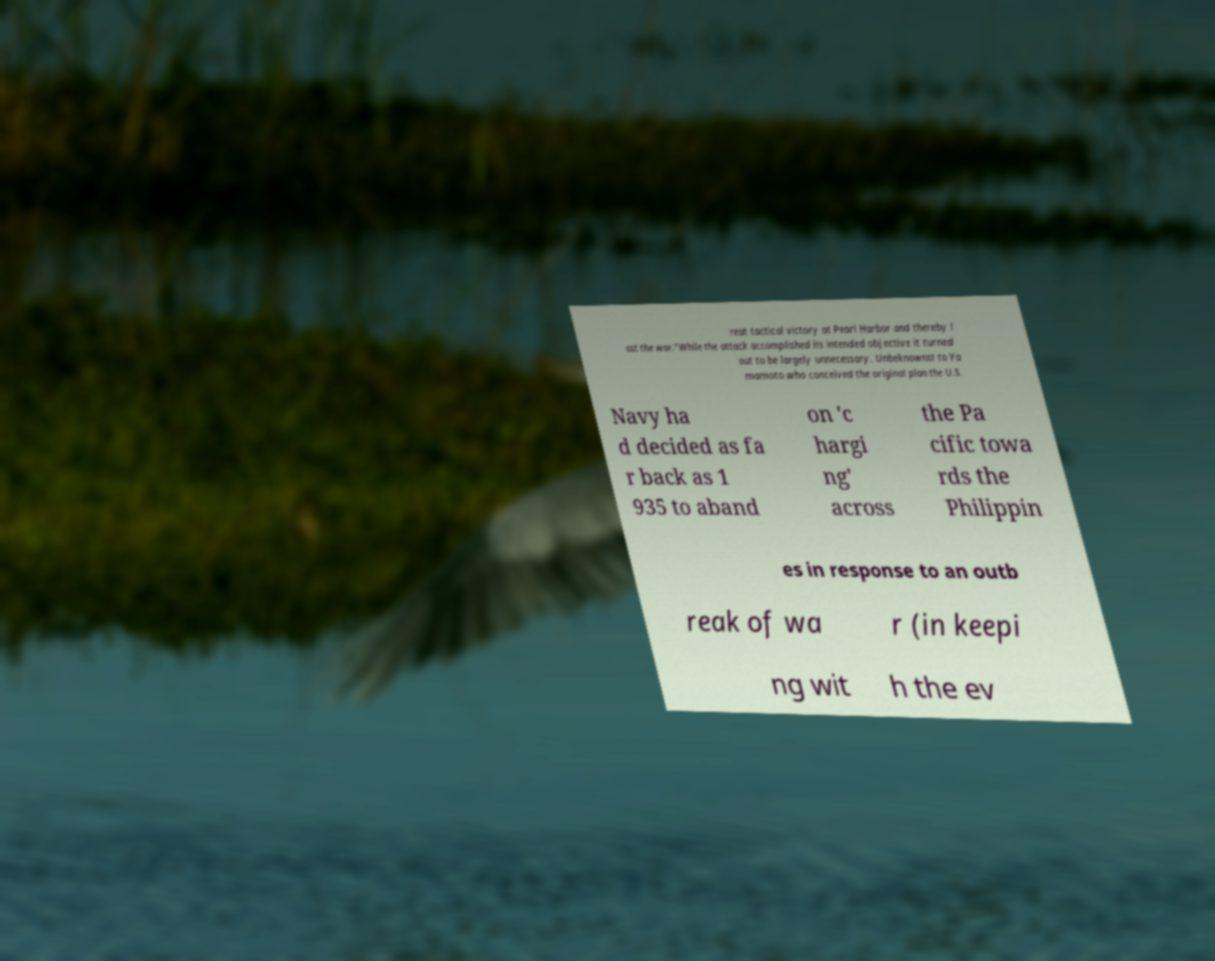Please read and relay the text visible in this image. What does it say? reat tactical victory at Pearl Harbor and thereby l ost the war."While the attack accomplished its intended objective it turned out to be largely unnecessary. Unbeknownst to Ya mamoto who conceived the original plan the U.S. Navy ha d decided as fa r back as 1 935 to aband on 'c hargi ng' across the Pa cific towa rds the Philippin es in response to an outb reak of wa r (in keepi ng wit h the ev 